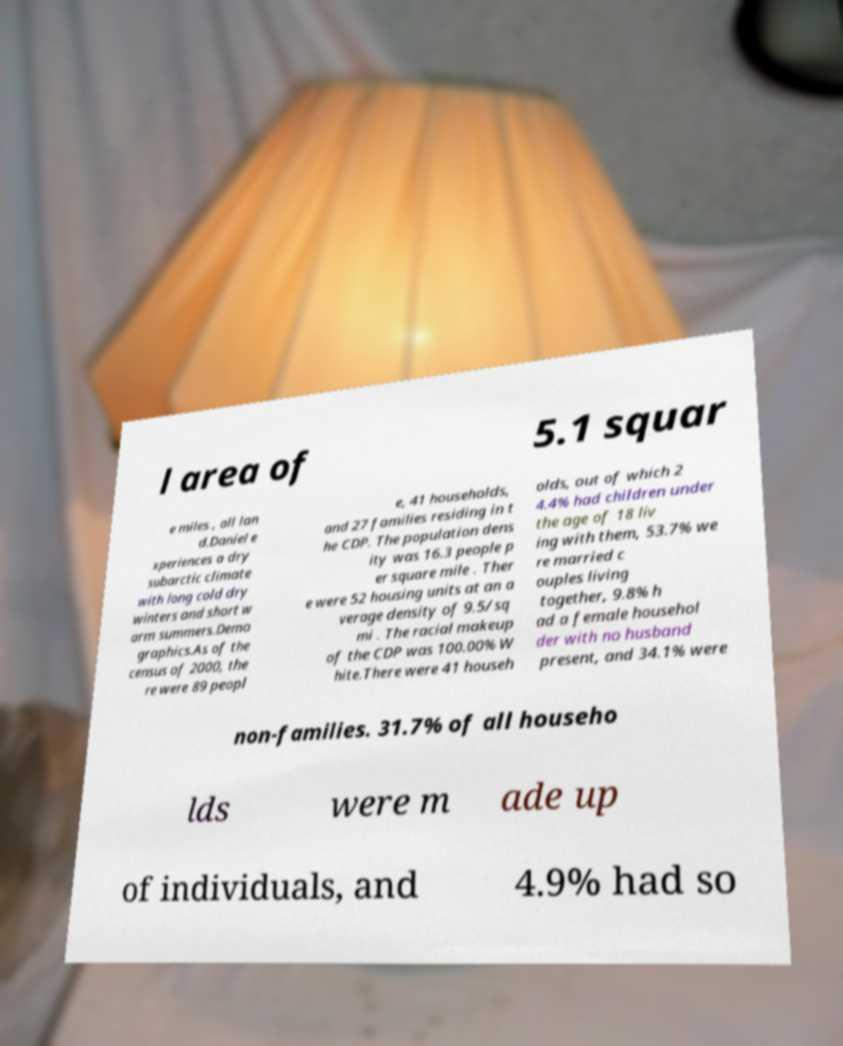Can you accurately transcribe the text from the provided image for me? l area of 5.1 squar e miles , all lan d.Daniel e xperiences a dry subarctic climate with long cold dry winters and short w arm summers.Demo graphics.As of the census of 2000, the re were 89 peopl e, 41 households, and 27 families residing in t he CDP. The population dens ity was 16.3 people p er square mile . Ther e were 52 housing units at an a verage density of 9.5/sq mi . The racial makeup of the CDP was 100.00% W hite.There were 41 househ olds, out of which 2 4.4% had children under the age of 18 liv ing with them, 53.7% we re married c ouples living together, 9.8% h ad a female househol der with no husband present, and 34.1% were non-families. 31.7% of all househo lds were m ade up of individuals, and 4.9% had so 